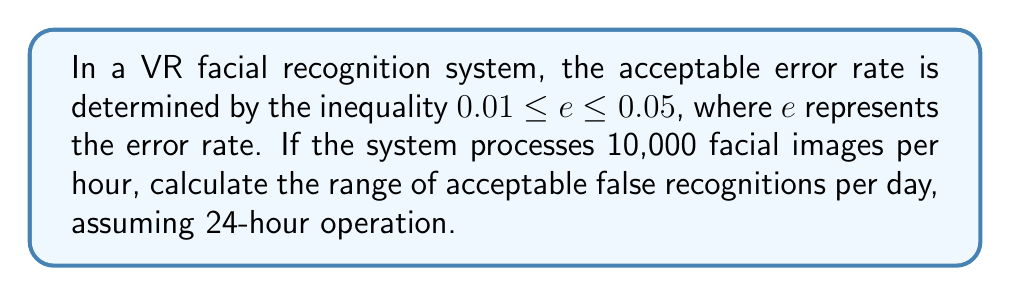Give your solution to this math problem. To solve this problem, we'll follow these steps:

1. Understand the given inequality:
   $0.01 \leq e \leq 0.05$, where $e$ is the error rate

2. Calculate the number of facial images processed per day:
   Images per hour = 10,000
   Hours per day = 24
   Images per day = $10,000 \times 24 = 240,000$

3. Calculate the lower bound of false recognitions:
   Lower bound error rate = 0.01
   Lower bound false recognitions = $240,000 \times 0.01 = 2,400$

4. Calculate the upper bound of false recognitions:
   Upper bound error rate = 0.05
   Upper bound false recognitions = $240,000 \times 0.05 = 12,000$

5. Express the range of acceptable false recognitions:
   $2,400 \leq \text{False Recognitions} \leq 12,000$

Thus, the range of acceptable false recognitions per day is between 2,400 and 12,000.
Answer: $2,400 \leq \text{False Recognitions} \leq 12,000$ 